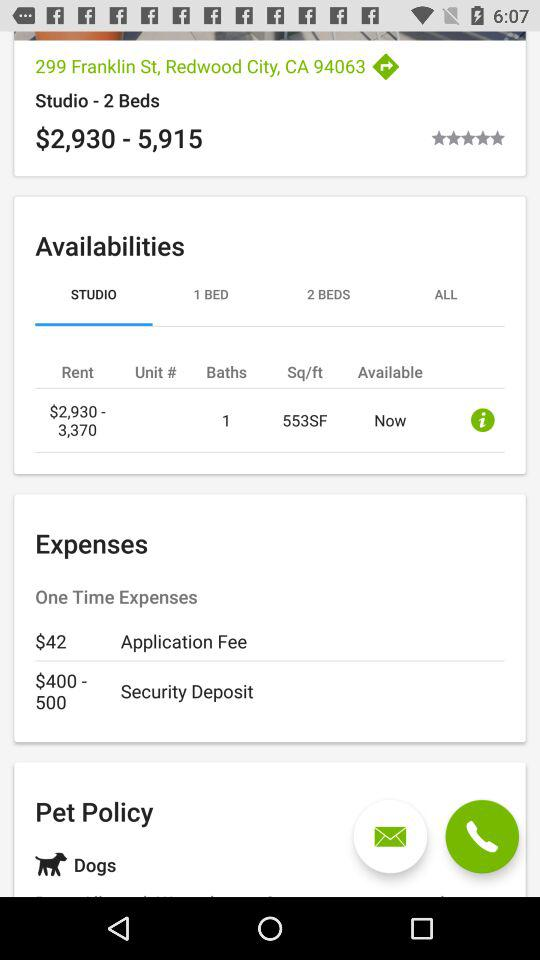What is the address given on the screen? The address given on the screen is 299 Franklin St, Redwood City, CA 94063. 